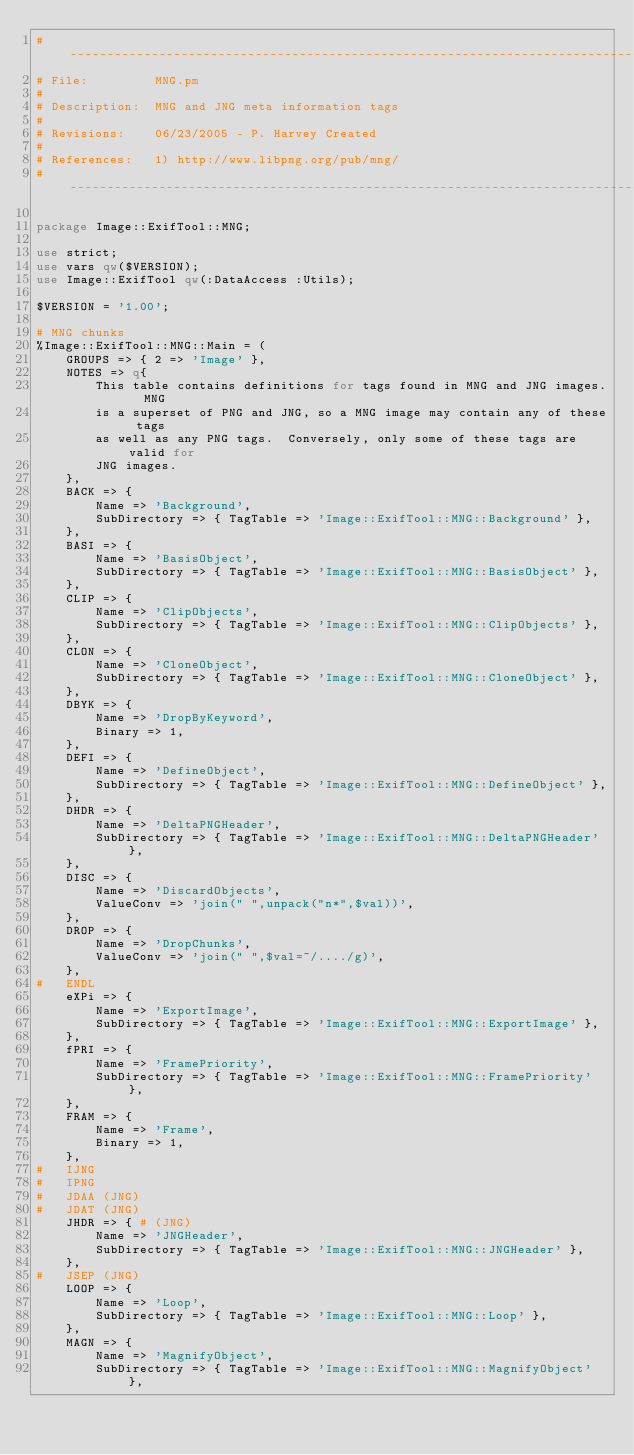Convert code to text. <code><loc_0><loc_0><loc_500><loc_500><_Perl_>#------------------------------------------------------------------------------
# File:         MNG.pm
#
# Description:  MNG and JNG meta information tags
#
# Revisions:    06/23/2005 - P. Harvey Created
#
# References:   1) http://www.libpng.org/pub/mng/
#------------------------------------------------------------------------------

package Image::ExifTool::MNG;

use strict;
use vars qw($VERSION);
use Image::ExifTool qw(:DataAccess :Utils);

$VERSION = '1.00';

# MNG chunks
%Image::ExifTool::MNG::Main = (
    GROUPS => { 2 => 'Image' },
    NOTES => q{
        This table contains definitions for tags found in MNG and JNG images.  MNG
        is a superset of PNG and JNG, so a MNG image may contain any of these tags
        as well as any PNG tags.  Conversely, only some of these tags are valid for
        JNG images.
    },
    BACK => {
        Name => 'Background',
        SubDirectory => { TagTable => 'Image::ExifTool::MNG::Background' },
    },
    BASI => {
        Name => 'BasisObject',
        SubDirectory => { TagTable => 'Image::ExifTool::MNG::BasisObject' },
    },
    CLIP => {
        Name => 'ClipObjects',
        SubDirectory => { TagTable => 'Image::ExifTool::MNG::ClipObjects' },
    },
    CLON => {
        Name => 'CloneObject',
        SubDirectory => { TagTable => 'Image::ExifTool::MNG::CloneObject' },
    },
    DBYK => {
        Name => 'DropByKeyword',
        Binary => 1,
    },
    DEFI => {
        Name => 'DefineObject',
        SubDirectory => { TagTable => 'Image::ExifTool::MNG::DefineObject' },
    },
    DHDR => {
        Name => 'DeltaPNGHeader',
        SubDirectory => { TagTable => 'Image::ExifTool::MNG::DeltaPNGHeader' },
    },
    DISC => {
        Name => 'DiscardObjects',
        ValueConv => 'join(" ",unpack("n*",$val))',
    },
    DROP => {
        Name => 'DropChunks',
        ValueConv => 'join(" ",$val=~/..../g)',
    },
#   ENDL
    eXPi => {
        Name => 'ExportImage',
        SubDirectory => { TagTable => 'Image::ExifTool::MNG::ExportImage' },
    },
    fPRI => {
        Name => 'FramePriority',
        SubDirectory => { TagTable => 'Image::ExifTool::MNG::FramePriority' },
    },
    FRAM => {
        Name => 'Frame',
        Binary => 1,
    },
#   IJNG
#   IPNG
#   JDAA (JNG)
#   JDAT (JNG)
    JHDR => { # (JNG)
        Name => 'JNGHeader',
        SubDirectory => { TagTable => 'Image::ExifTool::MNG::JNGHeader' },
    },
#   JSEP (JNG)
    LOOP => {
        Name => 'Loop',
        SubDirectory => { TagTable => 'Image::ExifTool::MNG::Loop' },
    },
    MAGN => {
        Name => 'MagnifyObject',
        SubDirectory => { TagTable => 'Image::ExifTool::MNG::MagnifyObject' },</code> 